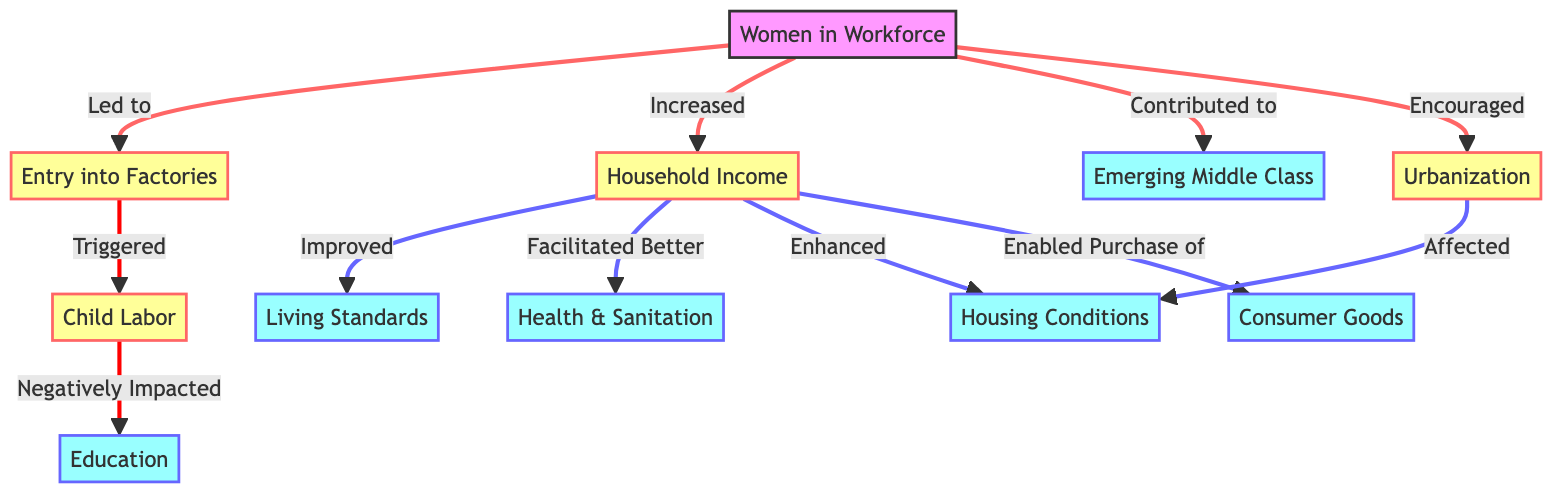What is the first node in the diagram? The first node in the diagram is labeled "Women in Workforce," which indicates the starting point of the flowchart.
Answer: Women in Workforce How many outcome nodes are present in the diagram? The diagram has five outcome nodes: "Living Standards," "Education," "Middle Class," "Health & Sanitation," and "Housing Conditions." Therefore, the total is five outcome nodes.
Answer: 5 What does "Household Income" improve according to the diagram? "Household Income" is said to improve "Living Standards," which indicates a direct relationship showing the positive impact of household income on living conditions.
Answer: Living Standards Which node is negatively impacted by "Child Labor"? The node "Education" is negatively impacted by "Child Labor," suggesting that the involvement of children in labor affects their ability to receive education.
Answer: Education How does "Women in Workforce" contribute to urbanization? "Women in Workforce" is connected to "Urbanization" with the label "Encouraged," meaning the participation of women in the workforce promotes the growth of urban areas during the Industrial Revolution.
Answer: Encouraged What effect does "Household Income" have on “Health & Sanitation”? The diagram points out that "Household Income" facilitates better "Health & Sanitation," indicating that increased income leads to improvements in health and sanitation conditions.
Answer: Facilitated Better What is the relationship between "Entry into Factories" and "Child Labor"? The connection indicates that "Entry into Factories" triggers "Child Labor," suggesting that as women entered the workforce, there was a subsequent rise in child labor.
Answer: Triggered Which socioeconomic factor is linked to the emergence of the middle class? The node "Middle Class" is connected to "Women in Workforce," indicating that women's participation in the workforce contributes to the establishment of an emerging middle class.
Answer: Emerging Middle Class What node has a direct link from "Urbanization"? The node "Housing Conditions" is directly affected by "Urbanization," showing how the growth of urban areas impacts people's living situations.
Answer: Housing Conditions 